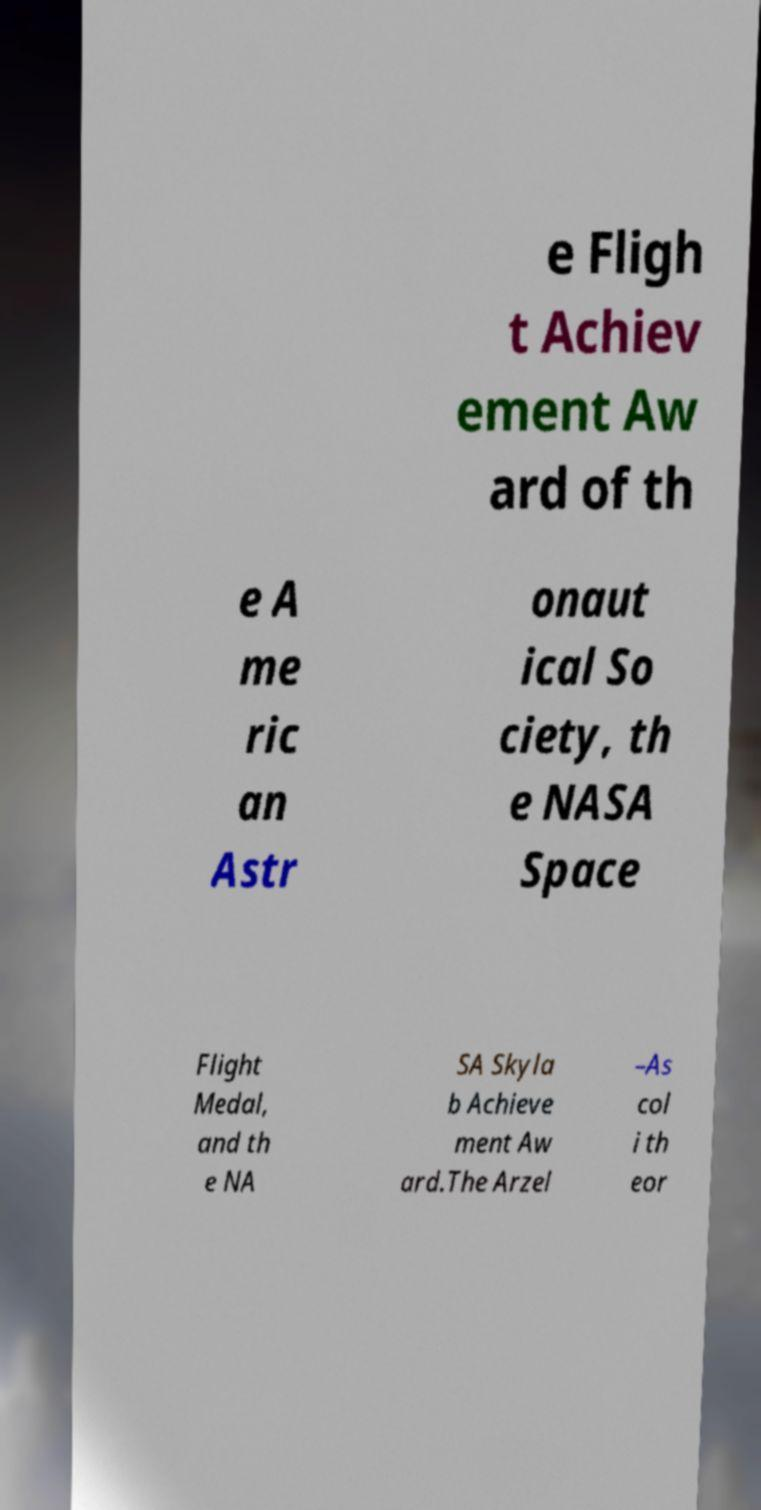Could you extract and type out the text from this image? e Fligh t Achiev ement Aw ard of th e A me ric an Astr onaut ical So ciety, th e NASA Space Flight Medal, and th e NA SA Skyla b Achieve ment Aw ard.The Arzel –As col i th eor 